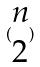Convert formula to latex. <formula><loc_0><loc_0><loc_500><loc_500>( \begin{matrix} n \\ 2 \end{matrix} )</formula> 